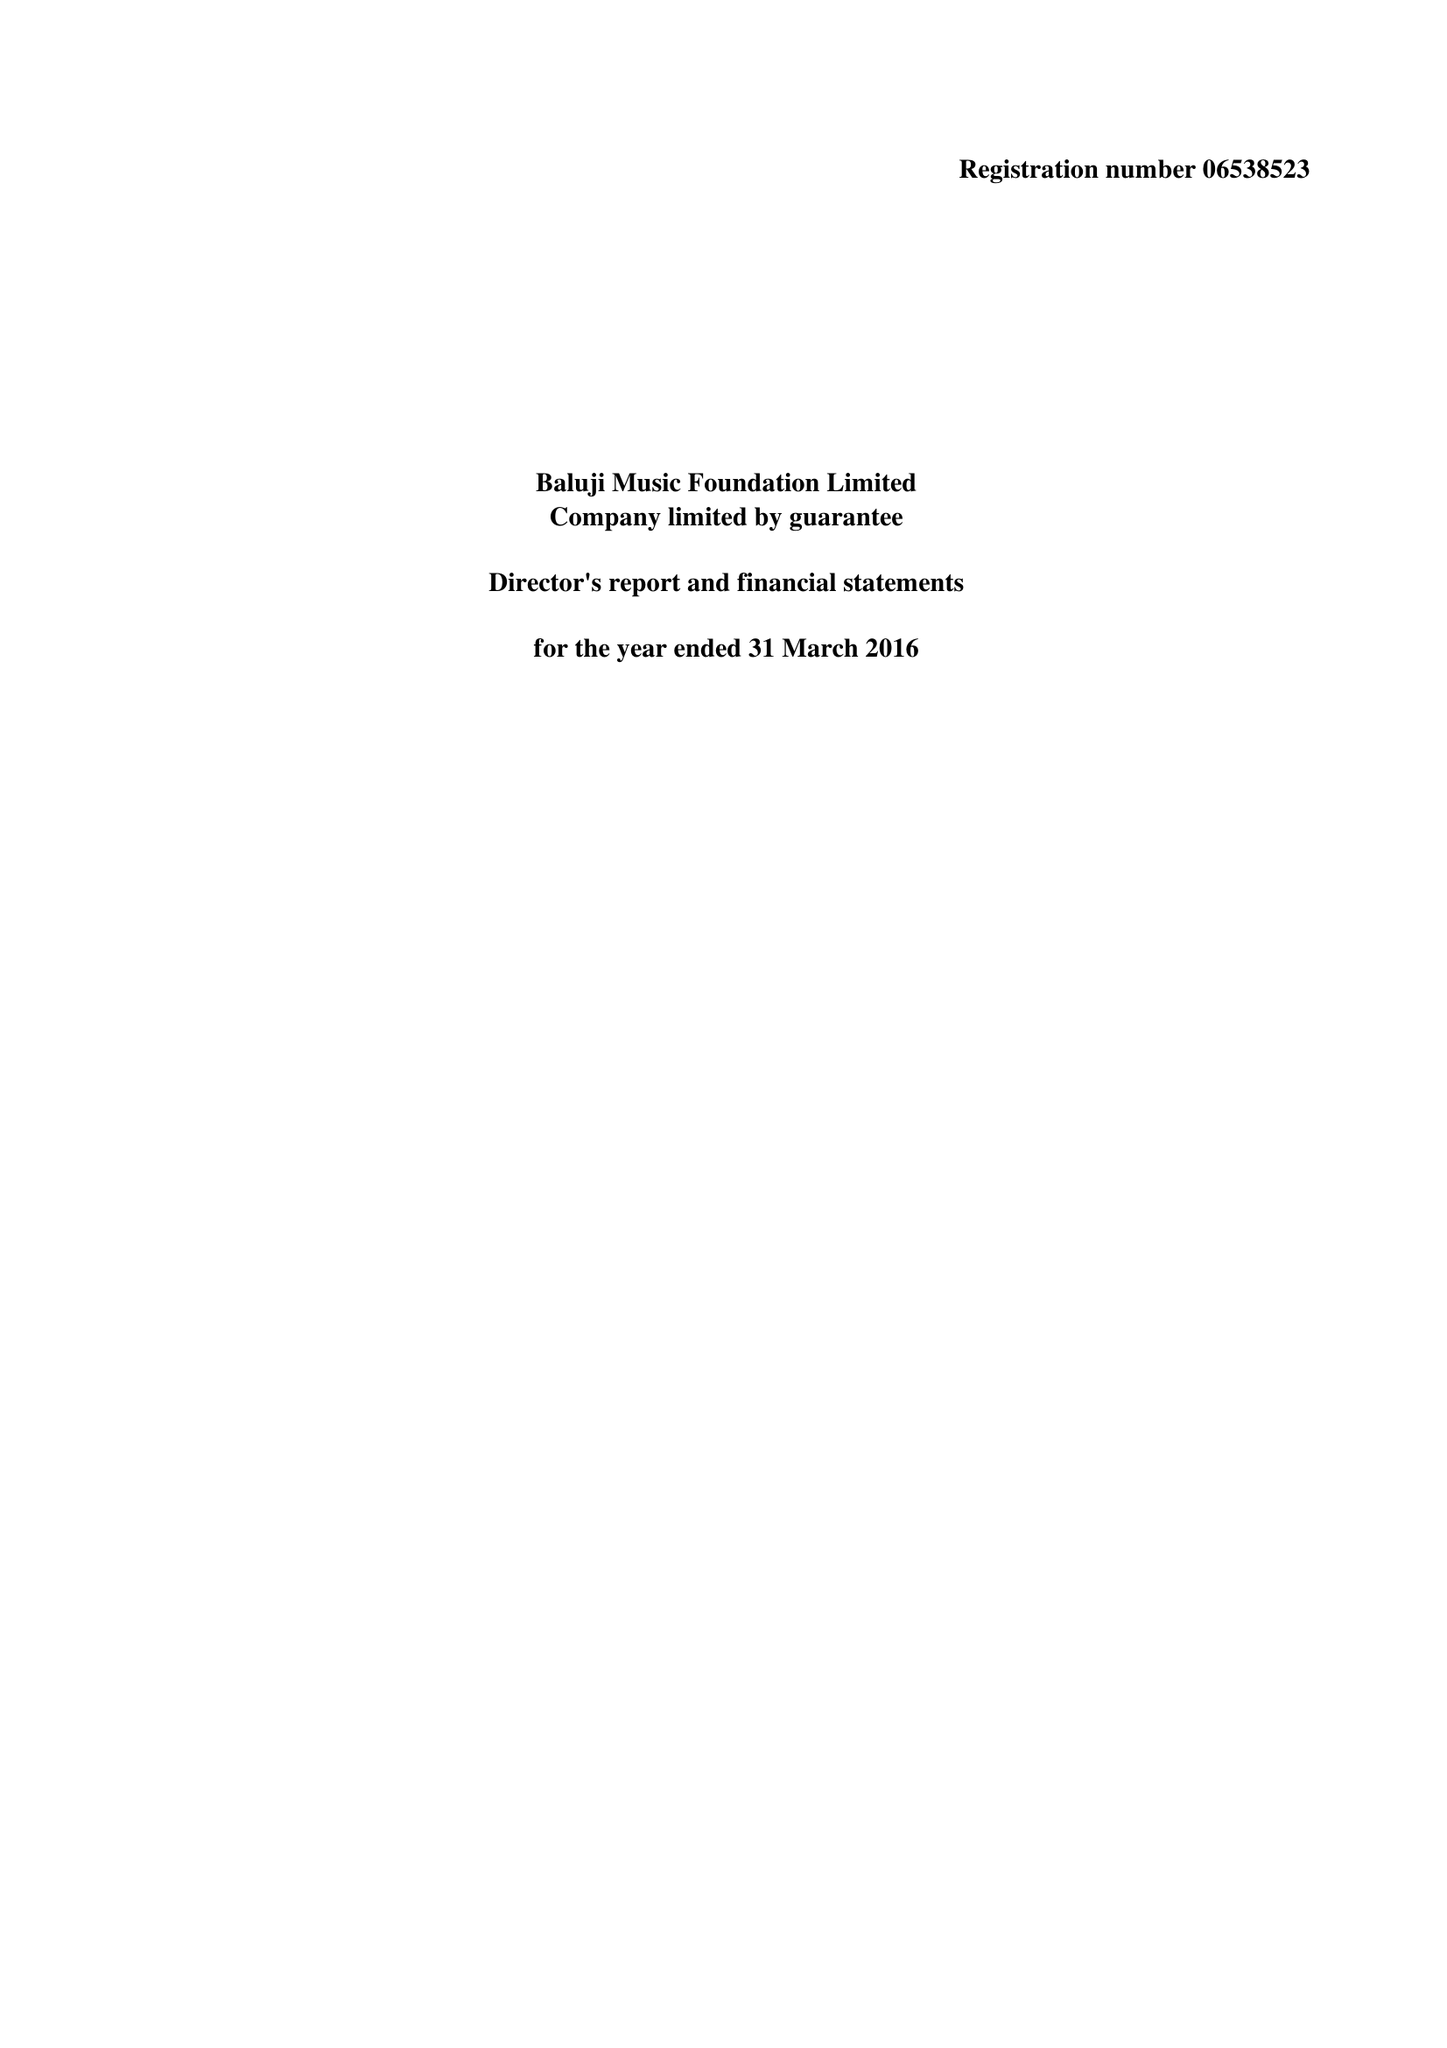What is the value for the charity_number?
Answer the question using a single word or phrase. 1130985 